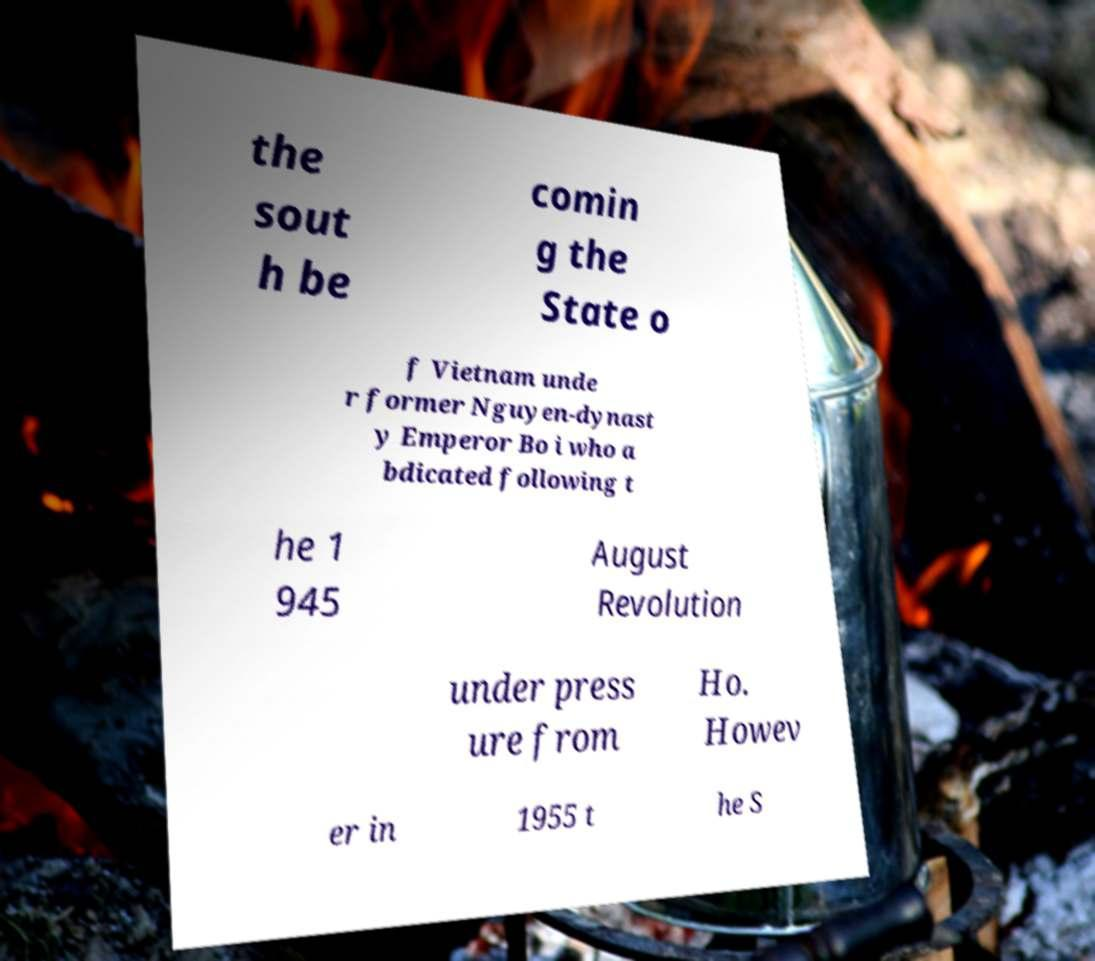Could you assist in decoding the text presented in this image and type it out clearly? the sout h be comin g the State o f Vietnam unde r former Nguyen-dynast y Emperor Bo i who a bdicated following t he 1 945 August Revolution under press ure from Ho. Howev er in 1955 t he S 